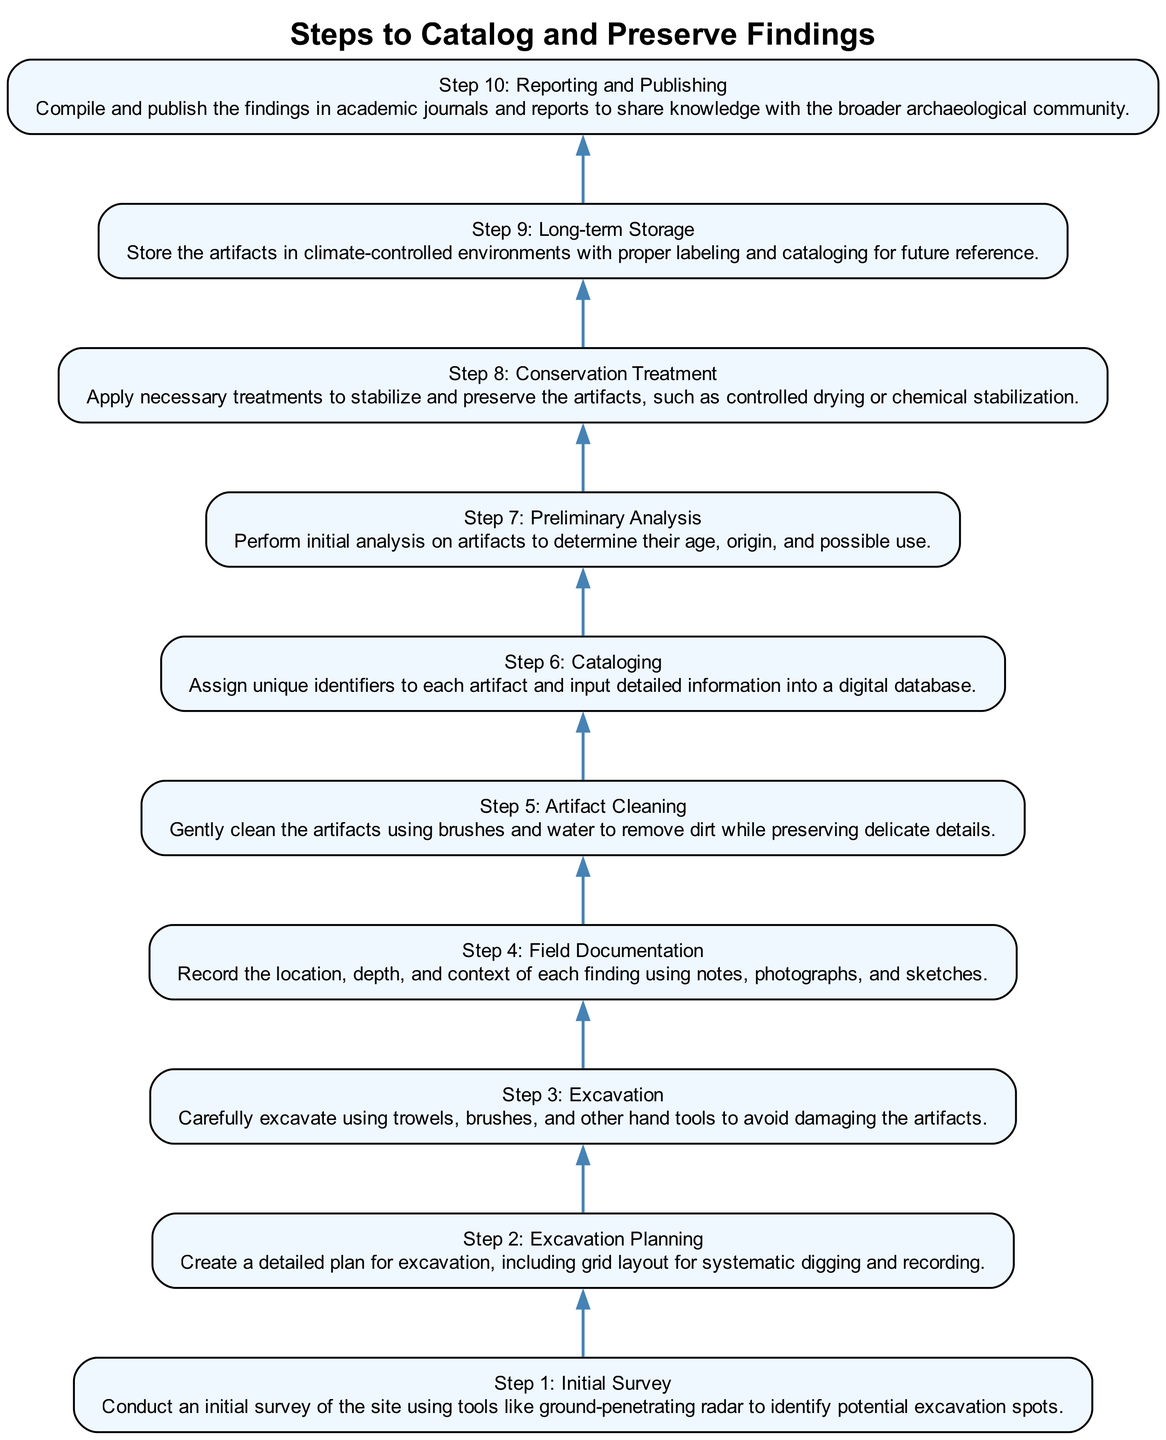What is the first step in the process? The diagram shows that the first step in the process of cataloging and preserving findings is labeled "Step 1: Initial Survey." This is the first node in the diagram, indicating it is the starting point.
Answer: Initial Survey What is the last step listed in the diagram? The last step in the diagram is "Step 10: Reporting and Publishing." It is located at the top of the flow chart, representing the final action in the process.
Answer: Reporting and Publishing How many total steps are included in the diagram? By counting the nodes in the flow chart from the bottom to the top, there are ten distinct steps illustrated in the diagram.
Answer: 10 What is the immediate step after Excavation? After "Step 3: Excavation," the diagram indicates that the next step is "Step 4: Field Documentation." This shows the direct flow from one step to the next.
Answer: Field Documentation Which step involves applying treatments for stabilization? In the diagram, "Step 8: Conservation Treatment" specifically mentions applying necessary treatments to stabilize and preserve the artifacts, making it the relevant step for this question.
Answer: Conservation Treatment Which two steps are directly connected to Artifact Cleaning? Looking at the flow chart, "Step 5: Artifact Cleaning" is preceded by "Step 4: Field Documentation" and is followed by "Step 6: Cataloging." These are the steps that connect directly to it, showing the flow before and after.
Answer: Field Documentation, Cataloging What common action is performed in both the Artifact Cleaning and Conservation Treatment steps? Both "Artifact Cleaning" and "Conservation Treatment" involve actions aimed at maintaining the integrity of the artifacts, focusing on cleaning and preserving them. This is a theme that bridges these two steps.
Answer: Maintaining integrity Identify the step focusing on preliminary evaluations of artifacts. The diagram clearly indicates "Step 7: Preliminary Analysis" as the step dedicated to initial evaluations of artifacts to determine various attributes such as their age and origin.
Answer: Preliminary Analysis What is the main goal of Long-term Storage? The purpose of "Step 9: Long-term Storage" is to ensure that artifacts are stored correctly, which includes climate control and proper cataloging for future reference, emphasizing preservation.
Answer: Preservation 